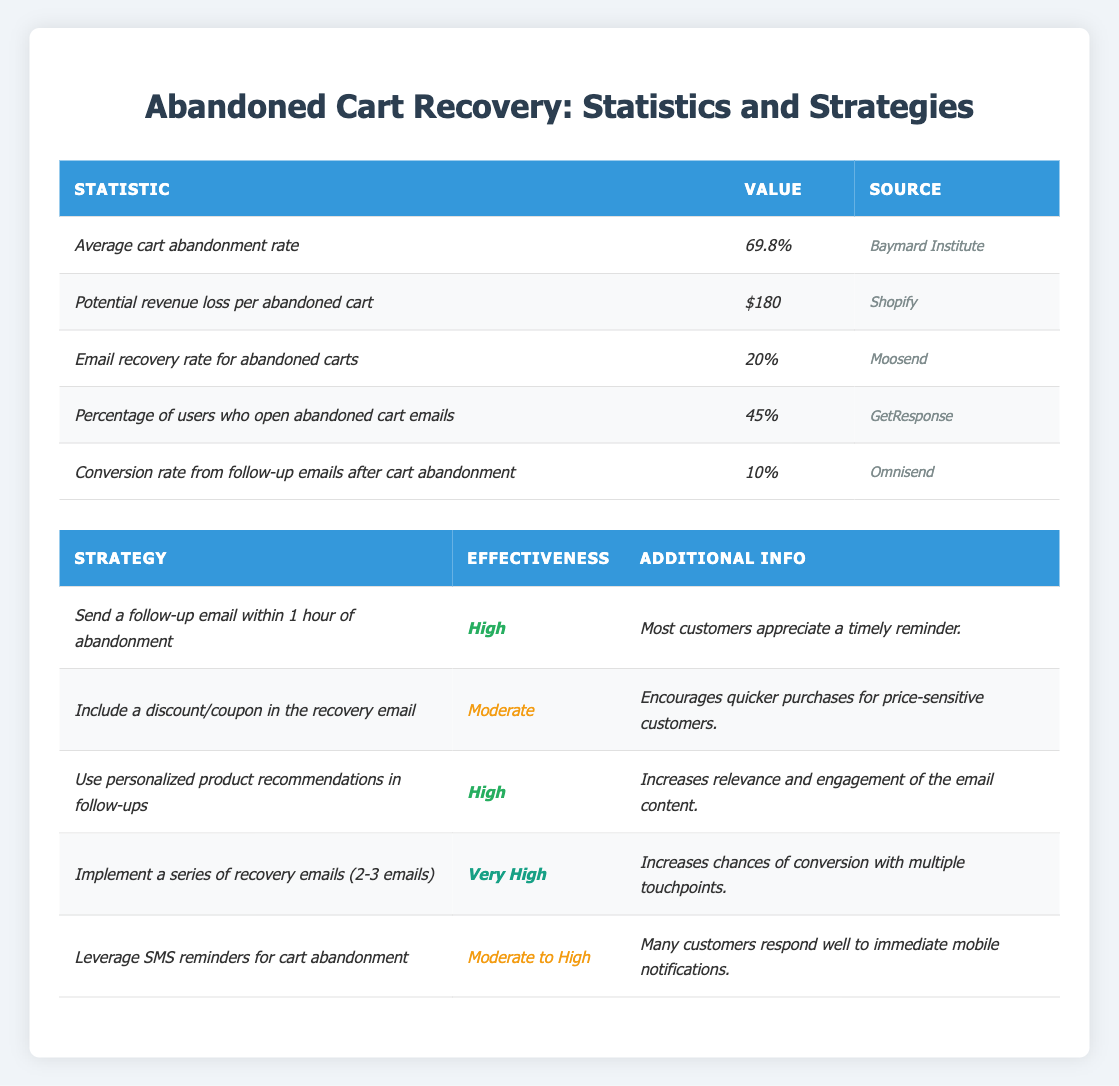What is the average cart abandonment rate? The table lists the average cart abandonment rate as *69.8%*.
Answer: 69.8% What is the potential revenue loss per abandoned cart? The table shows the potential revenue loss per abandoned cart as *$180*.
Answer: $180 What is the email recovery rate for abandoned carts? According to the table, the email recovery rate for abandoned carts is *20%*.
Answer: 20% What percentage of users open abandoned cart emails? The table indicates that *45%* of users open abandoned cart emails.
Answer: 45% What is the conversion rate from follow-up emails after cart abandonment? The table specifies that the conversion rate from follow-up emails after cart abandonment is *10%*.
Answer: 10% Which follow-up strategy has the highest effectiveness? The table shows that the strategy "Implement a series of recovery emails (2-3 emails)" is the most effective, rated as *Very High*.
Answer: Very High What additional information is provided for sending a follow-up email within 1 hour of abandonment? The table states that most customers appreciate a timely reminder when a follow-up email is sent within 1 hour of abandonment.
Answer: Most customers appreciate a timely reminder How many emails should be implemented for recovery to maximize chances of conversion? The table suggests implementing a series of 2-3 emails to increase conversion chances.
Answer: 2-3 emails What is the effectiveness of including a discount/coupon in the recovery email? The table lists it as having moderate effectiveness.
Answer: Moderate If 100 carts are abandoned, how many are likely to be recovered through email based on the email recovery rate? With an email recovery rate of *20%*, out of 100 abandoned carts, 20 are expected to be recovered (100 x 0.20 = 20).
Answer: 20 Which follow-up strategy would you choose if you were targeting price-sensitive customers? I would choose to include a discount/coupon in the recovery email, which has a moderate effectiveness.
Answer: Include a discount/coupon What is the effectiveness range for leveraging SMS reminders for cart abandonment? The table describes the effectiveness of leveraging SMS reminders as moderate to high.
Answer: Moderate to High Considering the average cart abandonment rate and conversion rate from follow-up emails, how many sales from 100 carts should you expect? With an abandonment rate of *69.8%* (leaving *30.2%* completed purchases), we can calculate potential recovery as *10%* of remaining abandoned carts: 100 carts - 69.8 abandoned = 30.2 completion; thus, 69.8 abandoned carts x 10% = about 7 recovered sales.
Answer: About 7 recovered sales What is the effectiveness of using personalized product recommendations in follow-ups? According to the table, using personalized product recommendations in follow-ups is rated *High*.
Answer: High 